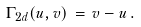Convert formula to latex. <formula><loc_0><loc_0><loc_500><loc_500>\Gamma _ { 2 d } ( u , v ) \, = \, v - u \, .</formula> 